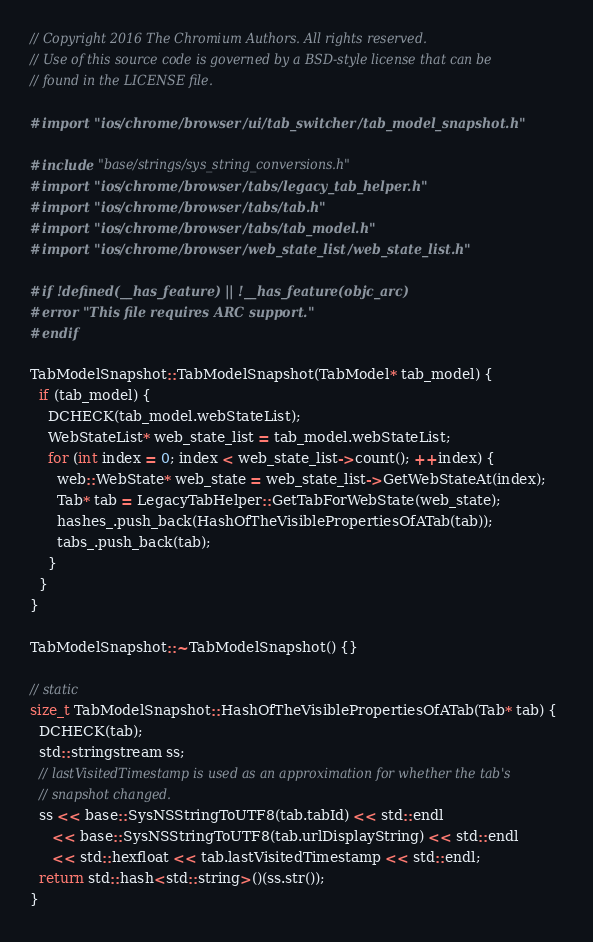<code> <loc_0><loc_0><loc_500><loc_500><_ObjectiveC_>// Copyright 2016 The Chromium Authors. All rights reserved.
// Use of this source code is governed by a BSD-style license that can be
// found in the LICENSE file.

#import "ios/chrome/browser/ui/tab_switcher/tab_model_snapshot.h"

#include "base/strings/sys_string_conversions.h"
#import "ios/chrome/browser/tabs/legacy_tab_helper.h"
#import "ios/chrome/browser/tabs/tab.h"
#import "ios/chrome/browser/tabs/tab_model.h"
#import "ios/chrome/browser/web_state_list/web_state_list.h"

#if !defined(__has_feature) || !__has_feature(objc_arc)
#error "This file requires ARC support."
#endif

TabModelSnapshot::TabModelSnapshot(TabModel* tab_model) {
  if (tab_model) {
    DCHECK(tab_model.webStateList);
    WebStateList* web_state_list = tab_model.webStateList;
    for (int index = 0; index < web_state_list->count(); ++index) {
      web::WebState* web_state = web_state_list->GetWebStateAt(index);
      Tab* tab = LegacyTabHelper::GetTabForWebState(web_state);
      hashes_.push_back(HashOfTheVisiblePropertiesOfATab(tab));
      tabs_.push_back(tab);
    }
  }
}

TabModelSnapshot::~TabModelSnapshot() {}

// static
size_t TabModelSnapshot::HashOfTheVisiblePropertiesOfATab(Tab* tab) {
  DCHECK(tab);
  std::stringstream ss;
  // lastVisitedTimestamp is used as an approximation for whether the tab's
  // snapshot changed.
  ss << base::SysNSStringToUTF8(tab.tabId) << std::endl
     << base::SysNSStringToUTF8(tab.urlDisplayString) << std::endl
     << std::hexfloat << tab.lastVisitedTimestamp << std::endl;
  return std::hash<std::string>()(ss.str());
}
</code> 